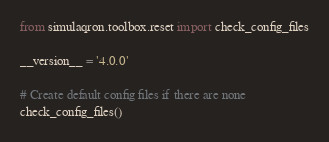Convert code to text. <code><loc_0><loc_0><loc_500><loc_500><_Python_>from simulaqron.toolbox.reset import check_config_files

__version__ = '4.0.0'

# Create default config files if there are none
check_config_files()
</code> 